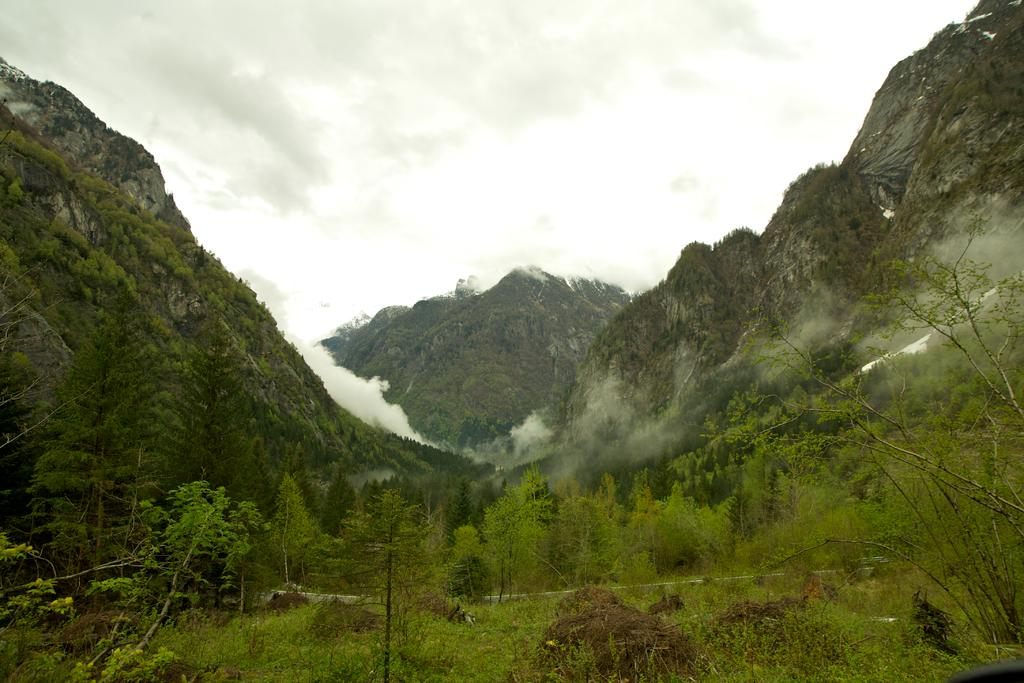What types of vegetation can be seen at the bottom of the image? Plants and trees are visible at the bottom of the image. What is covering the ground at the bottom of the image? Grass is present on the ground at the bottom of the image. What can be seen in the background of the image? There are mountains, smoke, and clouds visible in the background of the image. What type of mint is growing on the sofa in the image? There is no mint or sofa present in the image. What disease can be seen affecting the trees in the image? There is no disease affecting the trees in the image; they appear healthy. 